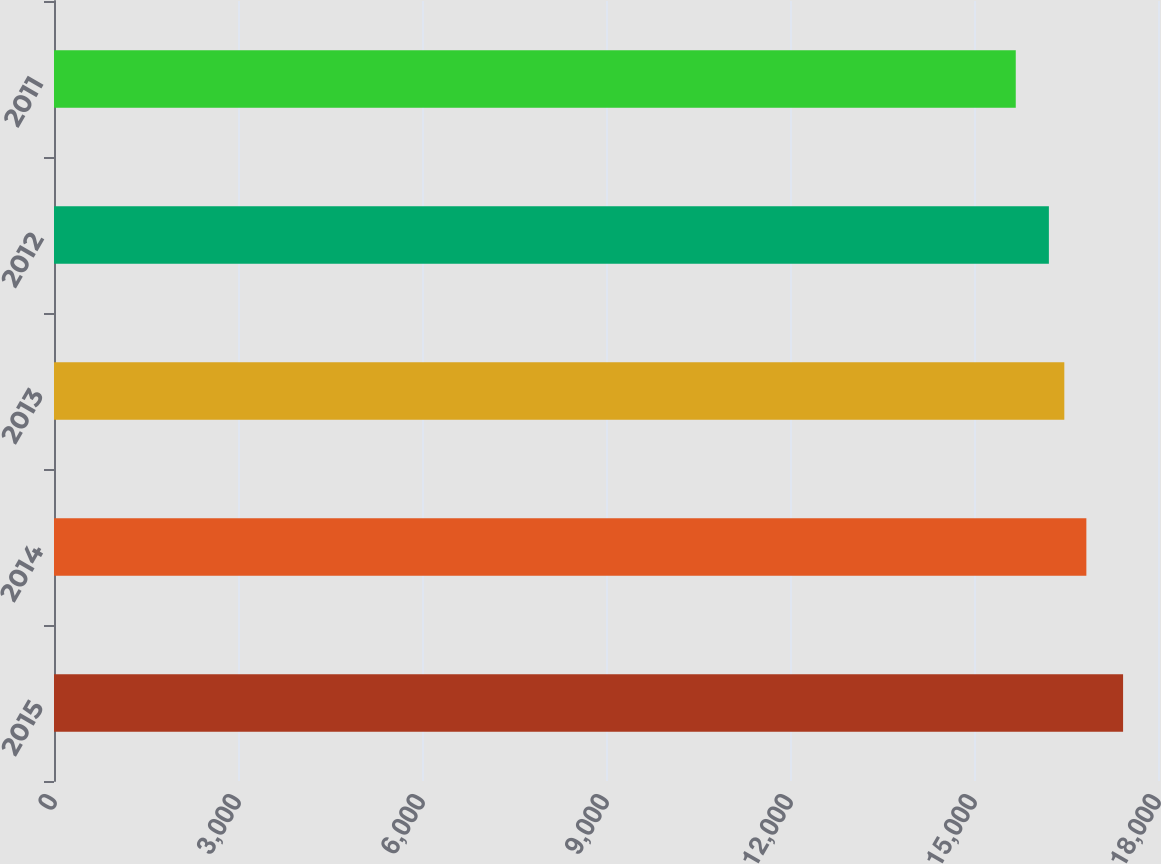Convert chart to OTSL. <chart><loc_0><loc_0><loc_500><loc_500><bar_chart><fcel>2015<fcel>2014<fcel>2013<fcel>2012<fcel>2011<nl><fcel>17430.8<fcel>16831.9<fcel>16472.5<fcel>16220.9<fcel>15680.9<nl></chart> 